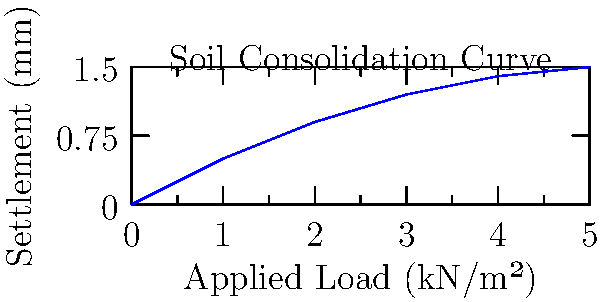Given a soil consolidation curve as shown in the graph, determine the settlement of a foundation when subjected to an applied load of 3.5 kN/m². The soil has an initial void ratio $e_0 = 0.8$, compression index $C_c = 0.2$, and the foundation depth is 2 meters. Calculate the settlement to the nearest millimeter. To calculate the settlement, we'll use the consolidation settlement equation:

$$S = \frac{C_c H}{1 + e_0} \log_{10}\left(\frac{p_0 + \Delta p}{p_0}\right)$$

Where:
$S$ = Settlement
$C_c$ = Compression index
$H$ = Foundation depth
$e_0$ = Initial void ratio
$p_0$ = Initial effective stress
$\Delta p$ = Change in stress (applied load)

Step 1: Calculate the initial effective stress at the center of the foundation:
$$p_0 = \gamma H/2 = 18 \text{ kN/m³} \times 1 \text{ m} = 18 \text{ kN/m²}$$
(Assuming soil unit weight $\gamma = 18 \text{ kN/m³}$)

Step 2: Determine $\Delta p$ from the applied load:
$$\Delta p = 3.5 \text{ kN/m²}$$

Step 3: Apply the consolidation settlement equation:
$$S = \frac{0.2 \times 2 \text{ m}}{1 + 0.8} \log_{10}\left(\frac{18 + 3.5}{18}\right)$$

Step 4: Calculate the settlement:
$$S = \frac{0.4}{1.8} \log_{10}(1.194) = 0.00187 \text{ m} = 1.87 \text{ mm}$$

Step 5: Round to the nearest millimeter:
$$S \approx 2 \text{ mm}$$
Answer: 2 mm 